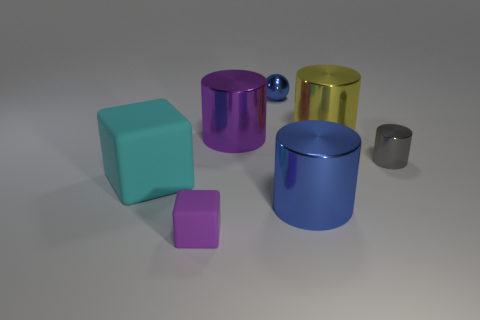Add 2 purple metallic cylinders. How many objects exist? 9 Subtract all cubes. How many objects are left? 5 Subtract all large objects. Subtract all yellow metallic things. How many objects are left? 2 Add 7 blue objects. How many blue objects are left? 9 Add 2 purple blocks. How many purple blocks exist? 3 Subtract 1 cyan blocks. How many objects are left? 6 